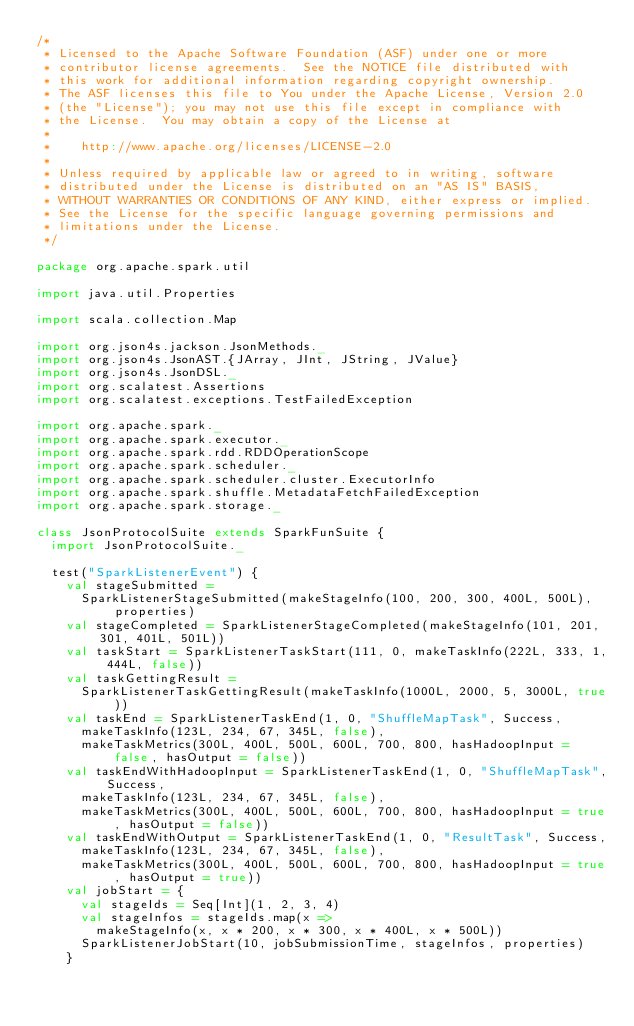<code> <loc_0><loc_0><loc_500><loc_500><_Scala_>/*
 * Licensed to the Apache Software Foundation (ASF) under one or more
 * contributor license agreements.  See the NOTICE file distributed with
 * this work for additional information regarding copyright ownership.
 * The ASF licenses this file to You under the Apache License, Version 2.0
 * (the "License"); you may not use this file except in compliance with
 * the License.  You may obtain a copy of the License at
 *
 *    http://www.apache.org/licenses/LICENSE-2.0
 *
 * Unless required by applicable law or agreed to in writing, software
 * distributed under the License is distributed on an "AS IS" BASIS,
 * WITHOUT WARRANTIES OR CONDITIONS OF ANY KIND, either express or implied.
 * See the License for the specific language governing permissions and
 * limitations under the License.
 */

package org.apache.spark.util

import java.util.Properties

import scala.collection.Map

import org.json4s.jackson.JsonMethods._
import org.json4s.JsonAST.{JArray, JInt, JString, JValue}
import org.json4s.JsonDSL._
import org.scalatest.Assertions
import org.scalatest.exceptions.TestFailedException

import org.apache.spark._
import org.apache.spark.executor._
import org.apache.spark.rdd.RDDOperationScope
import org.apache.spark.scheduler._
import org.apache.spark.scheduler.cluster.ExecutorInfo
import org.apache.spark.shuffle.MetadataFetchFailedException
import org.apache.spark.storage._

class JsonProtocolSuite extends SparkFunSuite {
  import JsonProtocolSuite._

  test("SparkListenerEvent") {
    val stageSubmitted =
      SparkListenerStageSubmitted(makeStageInfo(100, 200, 300, 400L, 500L), properties)
    val stageCompleted = SparkListenerStageCompleted(makeStageInfo(101, 201, 301, 401L, 501L))
    val taskStart = SparkListenerTaskStart(111, 0, makeTaskInfo(222L, 333, 1, 444L, false))
    val taskGettingResult =
      SparkListenerTaskGettingResult(makeTaskInfo(1000L, 2000, 5, 3000L, true))
    val taskEnd = SparkListenerTaskEnd(1, 0, "ShuffleMapTask", Success,
      makeTaskInfo(123L, 234, 67, 345L, false),
      makeTaskMetrics(300L, 400L, 500L, 600L, 700, 800, hasHadoopInput = false, hasOutput = false))
    val taskEndWithHadoopInput = SparkListenerTaskEnd(1, 0, "ShuffleMapTask", Success,
      makeTaskInfo(123L, 234, 67, 345L, false),
      makeTaskMetrics(300L, 400L, 500L, 600L, 700, 800, hasHadoopInput = true, hasOutput = false))
    val taskEndWithOutput = SparkListenerTaskEnd(1, 0, "ResultTask", Success,
      makeTaskInfo(123L, 234, 67, 345L, false),
      makeTaskMetrics(300L, 400L, 500L, 600L, 700, 800, hasHadoopInput = true, hasOutput = true))
    val jobStart = {
      val stageIds = Seq[Int](1, 2, 3, 4)
      val stageInfos = stageIds.map(x =>
        makeStageInfo(x, x * 200, x * 300, x * 400L, x * 500L))
      SparkListenerJobStart(10, jobSubmissionTime, stageInfos, properties)
    }</code> 